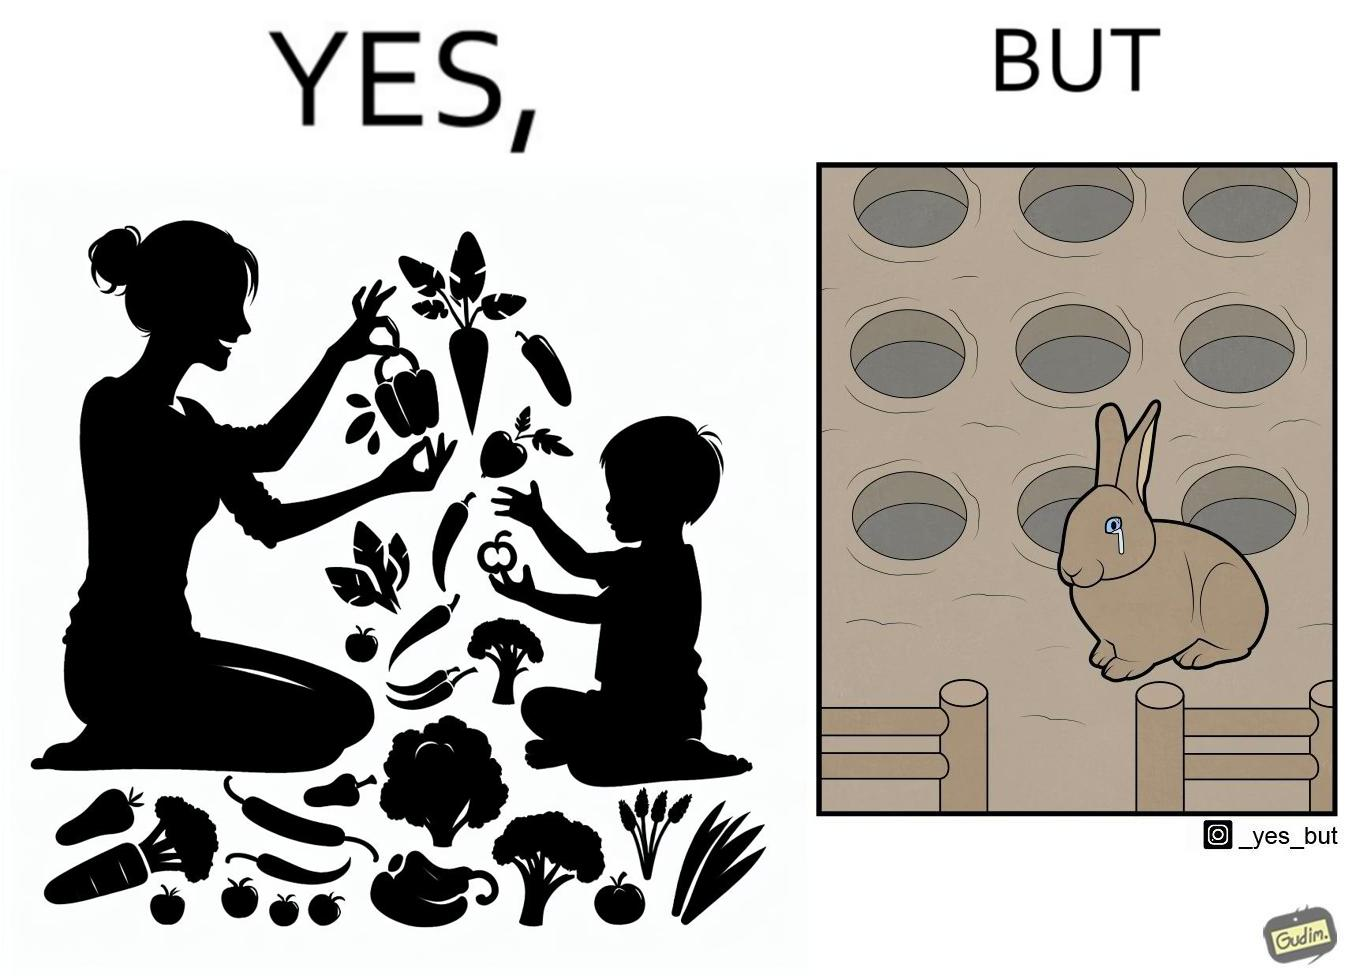Would you classify this image as satirical? Yes, this image is satirical. 